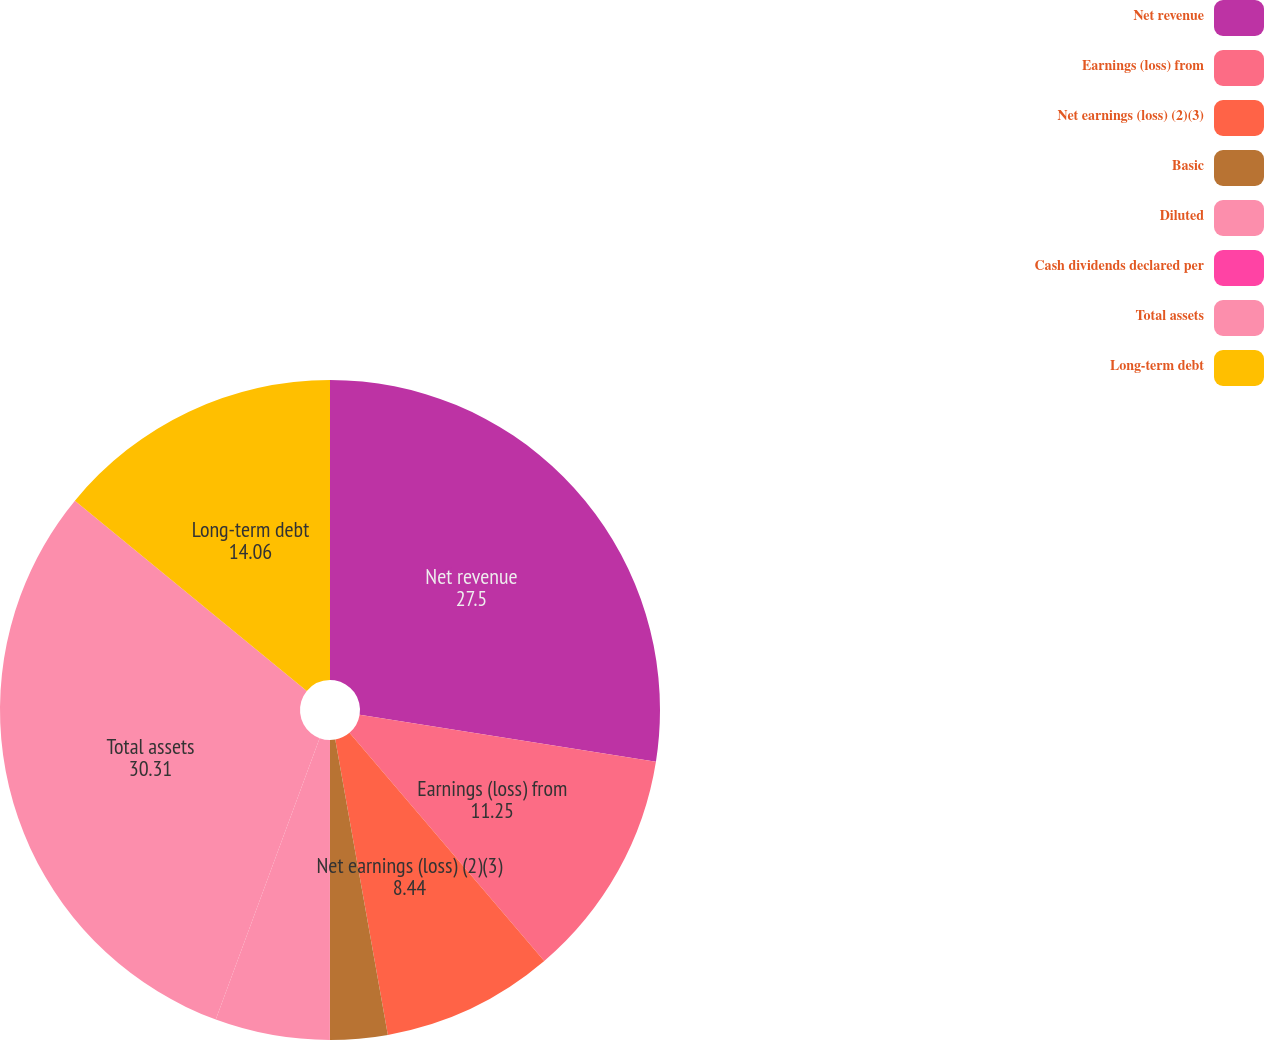Convert chart. <chart><loc_0><loc_0><loc_500><loc_500><pie_chart><fcel>Net revenue<fcel>Earnings (loss) from<fcel>Net earnings (loss) (2)(3)<fcel>Basic<fcel>Diluted<fcel>Cash dividends declared per<fcel>Total assets<fcel>Long-term debt<nl><fcel>27.5%<fcel>11.25%<fcel>8.44%<fcel>2.81%<fcel>5.62%<fcel>0.0%<fcel>30.31%<fcel>14.06%<nl></chart> 